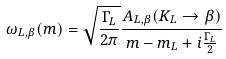<formula> <loc_0><loc_0><loc_500><loc_500>\omega _ { L , \beta } ( m ) = \sqrt { \frac { \Gamma _ { L } } { 2 \pi } } \frac { A _ { L , \beta } ( K _ { L } \rightarrow \beta ) } { m - m _ { L } + i \frac { \Gamma _ { L } } { 2 } }</formula> 